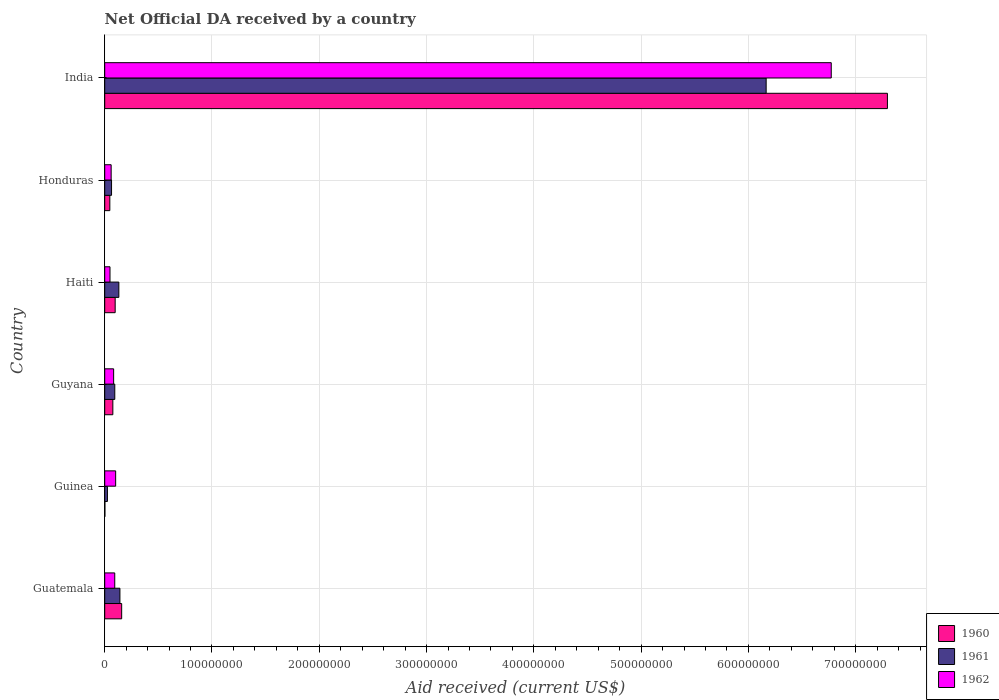Are the number of bars per tick equal to the number of legend labels?
Offer a very short reply. Yes. Are the number of bars on each tick of the Y-axis equal?
Your answer should be very brief. Yes. How many bars are there on the 5th tick from the top?
Offer a very short reply. 3. What is the label of the 6th group of bars from the top?
Make the answer very short. Guatemala. What is the net official development assistance aid received in 1961 in Honduras?
Offer a very short reply. 6.37e+06. Across all countries, what is the maximum net official development assistance aid received in 1961?
Ensure brevity in your answer.  6.17e+08. Across all countries, what is the minimum net official development assistance aid received in 1960?
Your response must be concise. 1.60e+05. In which country was the net official development assistance aid received in 1960 minimum?
Your response must be concise. Guinea. What is the total net official development assistance aid received in 1962 in the graph?
Keep it short and to the point. 7.16e+08. What is the difference between the net official development assistance aid received in 1960 in Guinea and that in Haiti?
Your answer should be very brief. -9.58e+06. What is the difference between the net official development assistance aid received in 1961 in Guyana and the net official development assistance aid received in 1960 in Haiti?
Your response must be concise. -3.60e+05. What is the average net official development assistance aid received in 1961 per country?
Provide a short and direct response. 1.10e+08. What is the difference between the net official development assistance aid received in 1962 and net official development assistance aid received in 1960 in Guyana?
Keep it short and to the point. 7.50e+05. In how many countries, is the net official development assistance aid received in 1962 greater than 500000000 US$?
Offer a very short reply. 1. What is the ratio of the net official development assistance aid received in 1961 in Guinea to that in Guyana?
Provide a short and direct response. 0.27. Is the difference between the net official development assistance aid received in 1962 in Haiti and India greater than the difference between the net official development assistance aid received in 1960 in Haiti and India?
Offer a terse response. Yes. What is the difference between the highest and the second highest net official development assistance aid received in 1962?
Ensure brevity in your answer.  6.67e+08. What is the difference between the highest and the lowest net official development assistance aid received in 1961?
Make the answer very short. 6.14e+08. Are the values on the major ticks of X-axis written in scientific E-notation?
Offer a very short reply. No. Does the graph contain grids?
Make the answer very short. Yes. What is the title of the graph?
Provide a succinct answer. Net Official DA received by a country. What is the label or title of the X-axis?
Your response must be concise. Aid received (current US$). What is the Aid received (current US$) in 1960 in Guatemala?
Provide a succinct answer. 1.58e+07. What is the Aid received (current US$) of 1961 in Guatemala?
Give a very brief answer. 1.42e+07. What is the Aid received (current US$) of 1962 in Guatemala?
Your answer should be compact. 9.35e+06. What is the Aid received (current US$) of 1960 in Guinea?
Provide a succinct answer. 1.60e+05. What is the Aid received (current US$) in 1961 in Guinea?
Provide a short and direct response. 2.53e+06. What is the Aid received (current US$) in 1962 in Guinea?
Offer a terse response. 1.02e+07. What is the Aid received (current US$) in 1960 in Guyana?
Give a very brief answer. 7.57e+06. What is the Aid received (current US$) in 1961 in Guyana?
Ensure brevity in your answer.  9.38e+06. What is the Aid received (current US$) of 1962 in Guyana?
Your answer should be very brief. 8.32e+06. What is the Aid received (current US$) in 1960 in Haiti?
Provide a succinct answer. 9.74e+06. What is the Aid received (current US$) in 1961 in Haiti?
Your response must be concise. 1.32e+07. What is the Aid received (current US$) of 1962 in Haiti?
Ensure brevity in your answer.  4.92e+06. What is the Aid received (current US$) in 1960 in Honduras?
Give a very brief answer. 4.77e+06. What is the Aid received (current US$) of 1961 in Honduras?
Your response must be concise. 6.37e+06. What is the Aid received (current US$) of 1960 in India?
Provide a succinct answer. 7.30e+08. What is the Aid received (current US$) of 1961 in India?
Offer a very short reply. 6.17e+08. What is the Aid received (current US$) in 1962 in India?
Ensure brevity in your answer.  6.77e+08. Across all countries, what is the maximum Aid received (current US$) in 1960?
Provide a succinct answer. 7.30e+08. Across all countries, what is the maximum Aid received (current US$) of 1961?
Keep it short and to the point. 6.17e+08. Across all countries, what is the maximum Aid received (current US$) in 1962?
Keep it short and to the point. 6.77e+08. Across all countries, what is the minimum Aid received (current US$) in 1961?
Keep it short and to the point. 2.53e+06. Across all countries, what is the minimum Aid received (current US$) of 1962?
Offer a very short reply. 4.92e+06. What is the total Aid received (current US$) of 1960 in the graph?
Ensure brevity in your answer.  7.68e+08. What is the total Aid received (current US$) in 1961 in the graph?
Ensure brevity in your answer.  6.62e+08. What is the total Aid received (current US$) of 1962 in the graph?
Provide a short and direct response. 7.16e+08. What is the difference between the Aid received (current US$) of 1960 in Guatemala and that in Guinea?
Make the answer very short. 1.56e+07. What is the difference between the Aid received (current US$) in 1961 in Guatemala and that in Guinea?
Give a very brief answer. 1.16e+07. What is the difference between the Aid received (current US$) in 1962 in Guatemala and that in Guinea?
Offer a very short reply. -8.40e+05. What is the difference between the Aid received (current US$) in 1960 in Guatemala and that in Guyana?
Make the answer very short. 8.24e+06. What is the difference between the Aid received (current US$) of 1961 in Guatemala and that in Guyana?
Offer a very short reply. 4.79e+06. What is the difference between the Aid received (current US$) in 1962 in Guatemala and that in Guyana?
Keep it short and to the point. 1.03e+06. What is the difference between the Aid received (current US$) in 1960 in Guatemala and that in Haiti?
Your answer should be very brief. 6.07e+06. What is the difference between the Aid received (current US$) in 1961 in Guatemala and that in Haiti?
Provide a succinct answer. 1.00e+06. What is the difference between the Aid received (current US$) in 1962 in Guatemala and that in Haiti?
Your response must be concise. 4.43e+06. What is the difference between the Aid received (current US$) of 1960 in Guatemala and that in Honduras?
Your answer should be very brief. 1.10e+07. What is the difference between the Aid received (current US$) in 1961 in Guatemala and that in Honduras?
Provide a succinct answer. 7.80e+06. What is the difference between the Aid received (current US$) of 1962 in Guatemala and that in Honduras?
Provide a succinct answer. 3.35e+06. What is the difference between the Aid received (current US$) of 1960 in Guatemala and that in India?
Give a very brief answer. -7.14e+08. What is the difference between the Aid received (current US$) of 1961 in Guatemala and that in India?
Your answer should be compact. -6.02e+08. What is the difference between the Aid received (current US$) of 1962 in Guatemala and that in India?
Offer a very short reply. -6.68e+08. What is the difference between the Aid received (current US$) of 1960 in Guinea and that in Guyana?
Keep it short and to the point. -7.41e+06. What is the difference between the Aid received (current US$) in 1961 in Guinea and that in Guyana?
Your answer should be compact. -6.85e+06. What is the difference between the Aid received (current US$) in 1962 in Guinea and that in Guyana?
Your answer should be very brief. 1.87e+06. What is the difference between the Aid received (current US$) of 1960 in Guinea and that in Haiti?
Give a very brief answer. -9.58e+06. What is the difference between the Aid received (current US$) of 1961 in Guinea and that in Haiti?
Provide a short and direct response. -1.06e+07. What is the difference between the Aid received (current US$) of 1962 in Guinea and that in Haiti?
Your response must be concise. 5.27e+06. What is the difference between the Aid received (current US$) in 1960 in Guinea and that in Honduras?
Offer a very short reply. -4.61e+06. What is the difference between the Aid received (current US$) in 1961 in Guinea and that in Honduras?
Your answer should be compact. -3.84e+06. What is the difference between the Aid received (current US$) of 1962 in Guinea and that in Honduras?
Your response must be concise. 4.19e+06. What is the difference between the Aid received (current US$) of 1960 in Guinea and that in India?
Provide a succinct answer. -7.29e+08. What is the difference between the Aid received (current US$) in 1961 in Guinea and that in India?
Make the answer very short. -6.14e+08. What is the difference between the Aid received (current US$) in 1962 in Guinea and that in India?
Provide a short and direct response. -6.67e+08. What is the difference between the Aid received (current US$) in 1960 in Guyana and that in Haiti?
Ensure brevity in your answer.  -2.17e+06. What is the difference between the Aid received (current US$) in 1961 in Guyana and that in Haiti?
Your response must be concise. -3.79e+06. What is the difference between the Aid received (current US$) in 1962 in Guyana and that in Haiti?
Your response must be concise. 3.40e+06. What is the difference between the Aid received (current US$) of 1960 in Guyana and that in Honduras?
Your response must be concise. 2.80e+06. What is the difference between the Aid received (current US$) in 1961 in Guyana and that in Honduras?
Your response must be concise. 3.01e+06. What is the difference between the Aid received (current US$) in 1962 in Guyana and that in Honduras?
Make the answer very short. 2.32e+06. What is the difference between the Aid received (current US$) in 1960 in Guyana and that in India?
Keep it short and to the point. -7.22e+08. What is the difference between the Aid received (current US$) in 1961 in Guyana and that in India?
Make the answer very short. -6.07e+08. What is the difference between the Aid received (current US$) of 1962 in Guyana and that in India?
Your answer should be compact. -6.69e+08. What is the difference between the Aid received (current US$) of 1960 in Haiti and that in Honduras?
Your response must be concise. 4.97e+06. What is the difference between the Aid received (current US$) in 1961 in Haiti and that in Honduras?
Your answer should be compact. 6.80e+06. What is the difference between the Aid received (current US$) in 1962 in Haiti and that in Honduras?
Your response must be concise. -1.08e+06. What is the difference between the Aid received (current US$) of 1960 in Haiti and that in India?
Offer a very short reply. -7.20e+08. What is the difference between the Aid received (current US$) in 1961 in Haiti and that in India?
Keep it short and to the point. -6.03e+08. What is the difference between the Aid received (current US$) in 1962 in Haiti and that in India?
Provide a succinct answer. -6.72e+08. What is the difference between the Aid received (current US$) in 1960 in Honduras and that in India?
Offer a terse response. -7.25e+08. What is the difference between the Aid received (current US$) in 1961 in Honduras and that in India?
Your answer should be very brief. -6.10e+08. What is the difference between the Aid received (current US$) in 1962 in Honduras and that in India?
Offer a terse response. -6.71e+08. What is the difference between the Aid received (current US$) of 1960 in Guatemala and the Aid received (current US$) of 1961 in Guinea?
Make the answer very short. 1.33e+07. What is the difference between the Aid received (current US$) in 1960 in Guatemala and the Aid received (current US$) in 1962 in Guinea?
Your answer should be very brief. 5.62e+06. What is the difference between the Aid received (current US$) of 1961 in Guatemala and the Aid received (current US$) of 1962 in Guinea?
Your answer should be very brief. 3.98e+06. What is the difference between the Aid received (current US$) of 1960 in Guatemala and the Aid received (current US$) of 1961 in Guyana?
Your response must be concise. 6.43e+06. What is the difference between the Aid received (current US$) in 1960 in Guatemala and the Aid received (current US$) in 1962 in Guyana?
Offer a terse response. 7.49e+06. What is the difference between the Aid received (current US$) of 1961 in Guatemala and the Aid received (current US$) of 1962 in Guyana?
Your response must be concise. 5.85e+06. What is the difference between the Aid received (current US$) of 1960 in Guatemala and the Aid received (current US$) of 1961 in Haiti?
Give a very brief answer. 2.64e+06. What is the difference between the Aid received (current US$) in 1960 in Guatemala and the Aid received (current US$) in 1962 in Haiti?
Your answer should be very brief. 1.09e+07. What is the difference between the Aid received (current US$) of 1961 in Guatemala and the Aid received (current US$) of 1962 in Haiti?
Your response must be concise. 9.25e+06. What is the difference between the Aid received (current US$) in 1960 in Guatemala and the Aid received (current US$) in 1961 in Honduras?
Provide a succinct answer. 9.44e+06. What is the difference between the Aid received (current US$) in 1960 in Guatemala and the Aid received (current US$) in 1962 in Honduras?
Your answer should be compact. 9.81e+06. What is the difference between the Aid received (current US$) of 1961 in Guatemala and the Aid received (current US$) of 1962 in Honduras?
Make the answer very short. 8.17e+06. What is the difference between the Aid received (current US$) in 1960 in Guatemala and the Aid received (current US$) in 1961 in India?
Make the answer very short. -6.01e+08. What is the difference between the Aid received (current US$) in 1960 in Guatemala and the Aid received (current US$) in 1962 in India?
Your answer should be compact. -6.61e+08. What is the difference between the Aid received (current US$) in 1961 in Guatemala and the Aid received (current US$) in 1962 in India?
Offer a terse response. -6.63e+08. What is the difference between the Aid received (current US$) in 1960 in Guinea and the Aid received (current US$) in 1961 in Guyana?
Provide a succinct answer. -9.22e+06. What is the difference between the Aid received (current US$) of 1960 in Guinea and the Aid received (current US$) of 1962 in Guyana?
Provide a short and direct response. -8.16e+06. What is the difference between the Aid received (current US$) of 1961 in Guinea and the Aid received (current US$) of 1962 in Guyana?
Offer a very short reply. -5.79e+06. What is the difference between the Aid received (current US$) in 1960 in Guinea and the Aid received (current US$) in 1961 in Haiti?
Ensure brevity in your answer.  -1.30e+07. What is the difference between the Aid received (current US$) in 1960 in Guinea and the Aid received (current US$) in 1962 in Haiti?
Keep it short and to the point. -4.76e+06. What is the difference between the Aid received (current US$) of 1961 in Guinea and the Aid received (current US$) of 1962 in Haiti?
Offer a very short reply. -2.39e+06. What is the difference between the Aid received (current US$) of 1960 in Guinea and the Aid received (current US$) of 1961 in Honduras?
Your answer should be very brief. -6.21e+06. What is the difference between the Aid received (current US$) in 1960 in Guinea and the Aid received (current US$) in 1962 in Honduras?
Give a very brief answer. -5.84e+06. What is the difference between the Aid received (current US$) in 1961 in Guinea and the Aid received (current US$) in 1962 in Honduras?
Ensure brevity in your answer.  -3.47e+06. What is the difference between the Aid received (current US$) in 1960 in Guinea and the Aid received (current US$) in 1961 in India?
Offer a terse response. -6.16e+08. What is the difference between the Aid received (current US$) in 1960 in Guinea and the Aid received (current US$) in 1962 in India?
Your answer should be compact. -6.77e+08. What is the difference between the Aid received (current US$) of 1961 in Guinea and the Aid received (current US$) of 1962 in India?
Offer a very short reply. -6.75e+08. What is the difference between the Aid received (current US$) in 1960 in Guyana and the Aid received (current US$) in 1961 in Haiti?
Make the answer very short. -5.60e+06. What is the difference between the Aid received (current US$) of 1960 in Guyana and the Aid received (current US$) of 1962 in Haiti?
Provide a short and direct response. 2.65e+06. What is the difference between the Aid received (current US$) of 1961 in Guyana and the Aid received (current US$) of 1962 in Haiti?
Ensure brevity in your answer.  4.46e+06. What is the difference between the Aid received (current US$) in 1960 in Guyana and the Aid received (current US$) in 1961 in Honduras?
Your response must be concise. 1.20e+06. What is the difference between the Aid received (current US$) in 1960 in Guyana and the Aid received (current US$) in 1962 in Honduras?
Keep it short and to the point. 1.57e+06. What is the difference between the Aid received (current US$) of 1961 in Guyana and the Aid received (current US$) of 1962 in Honduras?
Give a very brief answer. 3.38e+06. What is the difference between the Aid received (current US$) of 1960 in Guyana and the Aid received (current US$) of 1961 in India?
Your answer should be compact. -6.09e+08. What is the difference between the Aid received (current US$) in 1960 in Guyana and the Aid received (current US$) in 1962 in India?
Your answer should be compact. -6.70e+08. What is the difference between the Aid received (current US$) of 1961 in Guyana and the Aid received (current US$) of 1962 in India?
Provide a succinct answer. -6.68e+08. What is the difference between the Aid received (current US$) of 1960 in Haiti and the Aid received (current US$) of 1961 in Honduras?
Provide a short and direct response. 3.37e+06. What is the difference between the Aid received (current US$) in 1960 in Haiti and the Aid received (current US$) in 1962 in Honduras?
Your response must be concise. 3.74e+06. What is the difference between the Aid received (current US$) in 1961 in Haiti and the Aid received (current US$) in 1962 in Honduras?
Keep it short and to the point. 7.17e+06. What is the difference between the Aid received (current US$) in 1960 in Haiti and the Aid received (current US$) in 1961 in India?
Ensure brevity in your answer.  -6.07e+08. What is the difference between the Aid received (current US$) in 1960 in Haiti and the Aid received (current US$) in 1962 in India?
Give a very brief answer. -6.68e+08. What is the difference between the Aid received (current US$) of 1961 in Haiti and the Aid received (current US$) of 1962 in India?
Your response must be concise. -6.64e+08. What is the difference between the Aid received (current US$) of 1960 in Honduras and the Aid received (current US$) of 1961 in India?
Make the answer very short. -6.12e+08. What is the difference between the Aid received (current US$) in 1960 in Honduras and the Aid received (current US$) in 1962 in India?
Offer a terse response. -6.72e+08. What is the difference between the Aid received (current US$) in 1961 in Honduras and the Aid received (current US$) in 1962 in India?
Make the answer very short. -6.71e+08. What is the average Aid received (current US$) in 1960 per country?
Ensure brevity in your answer.  1.28e+08. What is the average Aid received (current US$) in 1961 per country?
Give a very brief answer. 1.10e+08. What is the average Aid received (current US$) in 1962 per country?
Your answer should be very brief. 1.19e+08. What is the difference between the Aid received (current US$) of 1960 and Aid received (current US$) of 1961 in Guatemala?
Your answer should be very brief. 1.64e+06. What is the difference between the Aid received (current US$) in 1960 and Aid received (current US$) in 1962 in Guatemala?
Offer a very short reply. 6.46e+06. What is the difference between the Aid received (current US$) of 1961 and Aid received (current US$) of 1962 in Guatemala?
Give a very brief answer. 4.82e+06. What is the difference between the Aid received (current US$) of 1960 and Aid received (current US$) of 1961 in Guinea?
Your answer should be very brief. -2.37e+06. What is the difference between the Aid received (current US$) of 1960 and Aid received (current US$) of 1962 in Guinea?
Keep it short and to the point. -1.00e+07. What is the difference between the Aid received (current US$) of 1961 and Aid received (current US$) of 1962 in Guinea?
Ensure brevity in your answer.  -7.66e+06. What is the difference between the Aid received (current US$) of 1960 and Aid received (current US$) of 1961 in Guyana?
Provide a short and direct response. -1.81e+06. What is the difference between the Aid received (current US$) in 1960 and Aid received (current US$) in 1962 in Guyana?
Your response must be concise. -7.50e+05. What is the difference between the Aid received (current US$) of 1961 and Aid received (current US$) of 1962 in Guyana?
Give a very brief answer. 1.06e+06. What is the difference between the Aid received (current US$) in 1960 and Aid received (current US$) in 1961 in Haiti?
Make the answer very short. -3.43e+06. What is the difference between the Aid received (current US$) of 1960 and Aid received (current US$) of 1962 in Haiti?
Your answer should be very brief. 4.82e+06. What is the difference between the Aid received (current US$) of 1961 and Aid received (current US$) of 1962 in Haiti?
Your answer should be compact. 8.25e+06. What is the difference between the Aid received (current US$) in 1960 and Aid received (current US$) in 1961 in Honduras?
Provide a short and direct response. -1.60e+06. What is the difference between the Aid received (current US$) in 1960 and Aid received (current US$) in 1962 in Honduras?
Your response must be concise. -1.23e+06. What is the difference between the Aid received (current US$) of 1960 and Aid received (current US$) of 1961 in India?
Make the answer very short. 1.13e+08. What is the difference between the Aid received (current US$) in 1960 and Aid received (current US$) in 1962 in India?
Provide a succinct answer. 5.24e+07. What is the difference between the Aid received (current US$) in 1961 and Aid received (current US$) in 1962 in India?
Your answer should be very brief. -6.07e+07. What is the ratio of the Aid received (current US$) in 1960 in Guatemala to that in Guinea?
Offer a very short reply. 98.81. What is the ratio of the Aid received (current US$) in 1961 in Guatemala to that in Guinea?
Give a very brief answer. 5.6. What is the ratio of the Aid received (current US$) of 1962 in Guatemala to that in Guinea?
Provide a succinct answer. 0.92. What is the ratio of the Aid received (current US$) of 1960 in Guatemala to that in Guyana?
Provide a short and direct response. 2.09. What is the ratio of the Aid received (current US$) of 1961 in Guatemala to that in Guyana?
Your answer should be compact. 1.51. What is the ratio of the Aid received (current US$) of 1962 in Guatemala to that in Guyana?
Provide a succinct answer. 1.12. What is the ratio of the Aid received (current US$) of 1960 in Guatemala to that in Haiti?
Keep it short and to the point. 1.62. What is the ratio of the Aid received (current US$) in 1961 in Guatemala to that in Haiti?
Your answer should be compact. 1.08. What is the ratio of the Aid received (current US$) of 1962 in Guatemala to that in Haiti?
Your response must be concise. 1.9. What is the ratio of the Aid received (current US$) of 1960 in Guatemala to that in Honduras?
Provide a short and direct response. 3.31. What is the ratio of the Aid received (current US$) in 1961 in Guatemala to that in Honduras?
Your answer should be very brief. 2.22. What is the ratio of the Aid received (current US$) in 1962 in Guatemala to that in Honduras?
Your answer should be very brief. 1.56. What is the ratio of the Aid received (current US$) in 1960 in Guatemala to that in India?
Provide a succinct answer. 0.02. What is the ratio of the Aid received (current US$) of 1961 in Guatemala to that in India?
Provide a short and direct response. 0.02. What is the ratio of the Aid received (current US$) in 1962 in Guatemala to that in India?
Your response must be concise. 0.01. What is the ratio of the Aid received (current US$) of 1960 in Guinea to that in Guyana?
Your answer should be very brief. 0.02. What is the ratio of the Aid received (current US$) in 1961 in Guinea to that in Guyana?
Make the answer very short. 0.27. What is the ratio of the Aid received (current US$) of 1962 in Guinea to that in Guyana?
Your answer should be very brief. 1.22. What is the ratio of the Aid received (current US$) of 1960 in Guinea to that in Haiti?
Provide a short and direct response. 0.02. What is the ratio of the Aid received (current US$) of 1961 in Guinea to that in Haiti?
Your answer should be very brief. 0.19. What is the ratio of the Aid received (current US$) in 1962 in Guinea to that in Haiti?
Your answer should be compact. 2.07. What is the ratio of the Aid received (current US$) in 1960 in Guinea to that in Honduras?
Your answer should be very brief. 0.03. What is the ratio of the Aid received (current US$) in 1961 in Guinea to that in Honduras?
Provide a succinct answer. 0.4. What is the ratio of the Aid received (current US$) of 1962 in Guinea to that in Honduras?
Ensure brevity in your answer.  1.7. What is the ratio of the Aid received (current US$) in 1961 in Guinea to that in India?
Your answer should be very brief. 0. What is the ratio of the Aid received (current US$) of 1962 in Guinea to that in India?
Your answer should be compact. 0.01. What is the ratio of the Aid received (current US$) of 1960 in Guyana to that in Haiti?
Provide a succinct answer. 0.78. What is the ratio of the Aid received (current US$) in 1961 in Guyana to that in Haiti?
Keep it short and to the point. 0.71. What is the ratio of the Aid received (current US$) in 1962 in Guyana to that in Haiti?
Ensure brevity in your answer.  1.69. What is the ratio of the Aid received (current US$) in 1960 in Guyana to that in Honduras?
Give a very brief answer. 1.59. What is the ratio of the Aid received (current US$) in 1961 in Guyana to that in Honduras?
Your answer should be very brief. 1.47. What is the ratio of the Aid received (current US$) in 1962 in Guyana to that in Honduras?
Your answer should be very brief. 1.39. What is the ratio of the Aid received (current US$) of 1960 in Guyana to that in India?
Your answer should be compact. 0.01. What is the ratio of the Aid received (current US$) of 1961 in Guyana to that in India?
Provide a succinct answer. 0.02. What is the ratio of the Aid received (current US$) in 1962 in Guyana to that in India?
Your response must be concise. 0.01. What is the ratio of the Aid received (current US$) in 1960 in Haiti to that in Honduras?
Give a very brief answer. 2.04. What is the ratio of the Aid received (current US$) in 1961 in Haiti to that in Honduras?
Make the answer very short. 2.07. What is the ratio of the Aid received (current US$) in 1962 in Haiti to that in Honduras?
Your answer should be compact. 0.82. What is the ratio of the Aid received (current US$) in 1960 in Haiti to that in India?
Your answer should be compact. 0.01. What is the ratio of the Aid received (current US$) of 1961 in Haiti to that in India?
Ensure brevity in your answer.  0.02. What is the ratio of the Aid received (current US$) of 1962 in Haiti to that in India?
Keep it short and to the point. 0.01. What is the ratio of the Aid received (current US$) in 1960 in Honduras to that in India?
Provide a short and direct response. 0.01. What is the ratio of the Aid received (current US$) in 1961 in Honduras to that in India?
Keep it short and to the point. 0.01. What is the ratio of the Aid received (current US$) in 1962 in Honduras to that in India?
Your answer should be compact. 0.01. What is the difference between the highest and the second highest Aid received (current US$) of 1960?
Give a very brief answer. 7.14e+08. What is the difference between the highest and the second highest Aid received (current US$) of 1961?
Your response must be concise. 6.02e+08. What is the difference between the highest and the second highest Aid received (current US$) in 1962?
Offer a terse response. 6.67e+08. What is the difference between the highest and the lowest Aid received (current US$) in 1960?
Offer a very short reply. 7.29e+08. What is the difference between the highest and the lowest Aid received (current US$) in 1961?
Your answer should be very brief. 6.14e+08. What is the difference between the highest and the lowest Aid received (current US$) of 1962?
Your answer should be compact. 6.72e+08. 